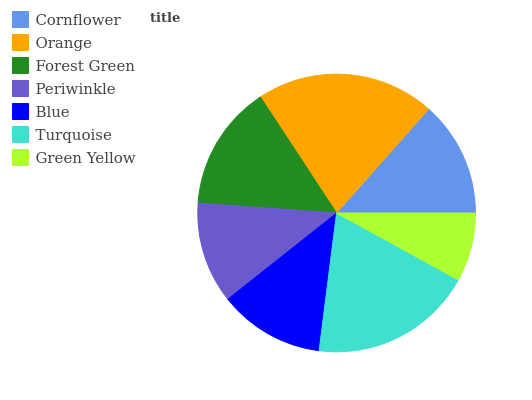Is Green Yellow the minimum?
Answer yes or no. Yes. Is Orange the maximum?
Answer yes or no. Yes. Is Forest Green the minimum?
Answer yes or no. No. Is Forest Green the maximum?
Answer yes or no. No. Is Orange greater than Forest Green?
Answer yes or no. Yes. Is Forest Green less than Orange?
Answer yes or no. Yes. Is Forest Green greater than Orange?
Answer yes or no. No. Is Orange less than Forest Green?
Answer yes or no. No. Is Cornflower the high median?
Answer yes or no. Yes. Is Cornflower the low median?
Answer yes or no. Yes. Is Green Yellow the high median?
Answer yes or no. No. Is Orange the low median?
Answer yes or no. No. 